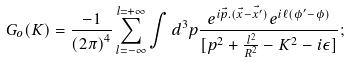Convert formula to latex. <formula><loc_0><loc_0><loc_500><loc_500>G _ { o } ( K ) = \frac { - 1 } { { ( 2 \pi ) } ^ { 4 } } \sum _ { l = - \infty } ^ { l = + \infty } \int d ^ { 3 } p \frac { e ^ { i \vec { p } . ( \vec { x } - \vec { x ^ { \prime } } ) } e ^ { i \ell ( \phi ^ { \prime } - \phi ) } } { [ p ^ { 2 } + \frac { l ^ { 2 } } { R ^ { 2 } } - K ^ { 2 } - i \epsilon ] } ;</formula> 